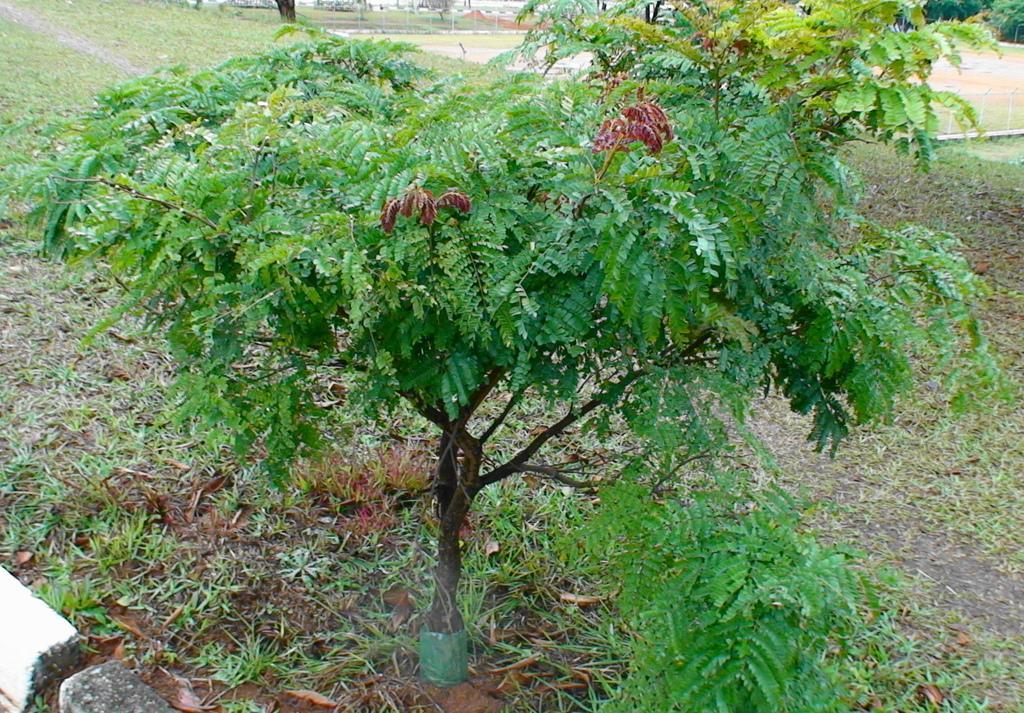Describe this image in one or two sentences. In this image I can see an open green grass ground and here I can see a tree. 